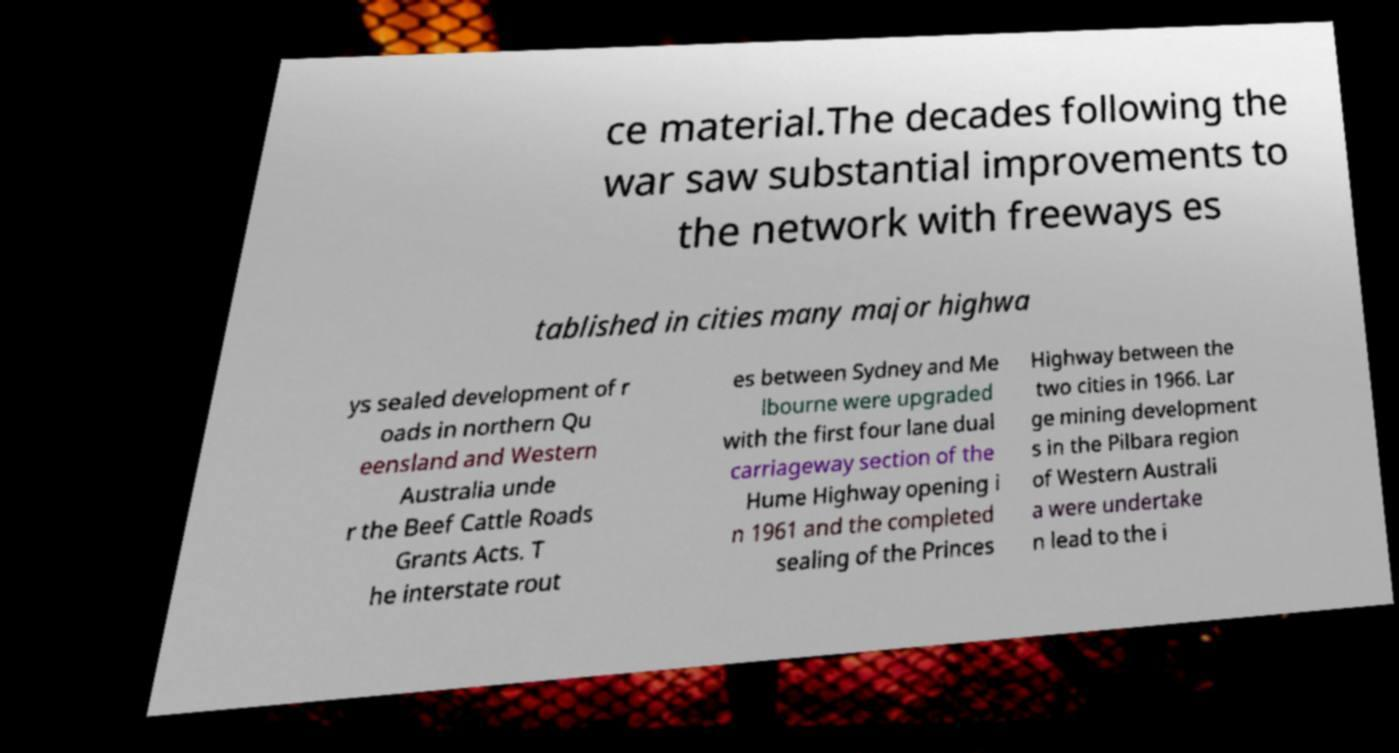There's text embedded in this image that I need extracted. Can you transcribe it verbatim? ce material.The decades following the war saw substantial improvements to the network with freeways es tablished in cities many major highwa ys sealed development of r oads in northern Qu eensland and Western Australia unde r the Beef Cattle Roads Grants Acts. T he interstate rout es between Sydney and Me lbourne were upgraded with the first four lane dual carriageway section of the Hume Highway opening i n 1961 and the completed sealing of the Princes Highway between the two cities in 1966. Lar ge mining development s in the Pilbara region of Western Australi a were undertake n lead to the i 